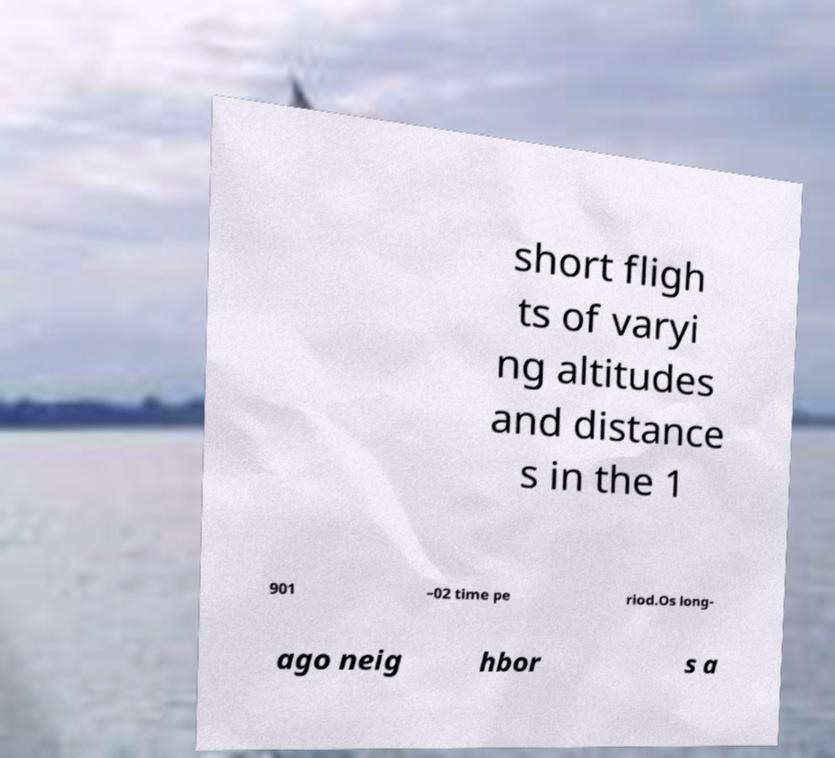What messages or text are displayed in this image? I need them in a readable, typed format. short fligh ts of varyi ng altitudes and distance s in the 1 901 –02 time pe riod.Os long- ago neig hbor s a 